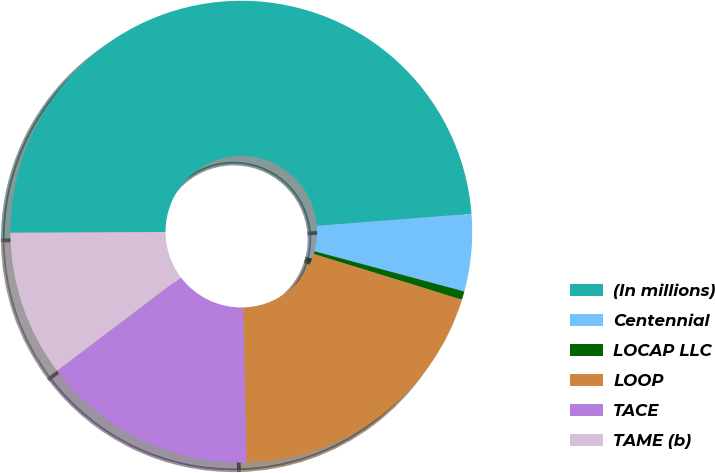Convert chart. <chart><loc_0><loc_0><loc_500><loc_500><pie_chart><fcel>(In millions)<fcel>Centennial<fcel>LOCAP LLC<fcel>LOOP<fcel>TACE<fcel>TAME (b)<nl><fcel>48.84%<fcel>5.41%<fcel>0.58%<fcel>19.88%<fcel>15.06%<fcel>10.23%<nl></chart> 